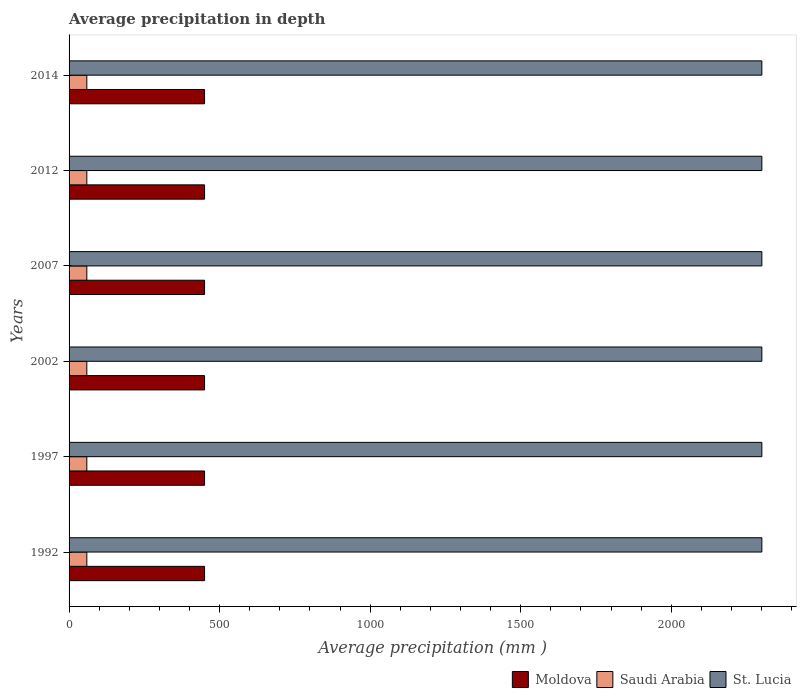Are the number of bars on each tick of the Y-axis equal?
Your response must be concise. Yes. How many bars are there on the 2nd tick from the bottom?
Your response must be concise. 3. In how many cases, is the number of bars for a given year not equal to the number of legend labels?
Your answer should be compact. 0. What is the average precipitation in Saudi Arabia in 1997?
Your answer should be compact. 59. Across all years, what is the maximum average precipitation in Moldova?
Provide a succinct answer. 450. Across all years, what is the minimum average precipitation in Saudi Arabia?
Ensure brevity in your answer.  59. What is the total average precipitation in St. Lucia in the graph?
Make the answer very short. 1.38e+04. What is the difference between the average precipitation in Moldova in 2014 and the average precipitation in Saudi Arabia in 2012?
Provide a short and direct response. 391. What is the average average precipitation in St. Lucia per year?
Your answer should be very brief. 2301. In the year 1997, what is the difference between the average precipitation in Saudi Arabia and average precipitation in Moldova?
Offer a terse response. -391. What is the ratio of the average precipitation in Moldova in 2002 to that in 2012?
Offer a very short reply. 1. Is the difference between the average precipitation in Saudi Arabia in 2007 and 2014 greater than the difference between the average precipitation in Moldova in 2007 and 2014?
Provide a succinct answer. No. What is the difference between the highest and the second highest average precipitation in Saudi Arabia?
Ensure brevity in your answer.  0. What is the difference between the highest and the lowest average precipitation in Saudi Arabia?
Offer a terse response. 0. In how many years, is the average precipitation in Moldova greater than the average average precipitation in Moldova taken over all years?
Provide a succinct answer. 0. What does the 1st bar from the top in 2014 represents?
Provide a succinct answer. St. Lucia. What does the 2nd bar from the bottom in 1997 represents?
Give a very brief answer. Saudi Arabia. Is it the case that in every year, the sum of the average precipitation in St. Lucia and average precipitation in Moldova is greater than the average precipitation in Saudi Arabia?
Your response must be concise. Yes. How many bars are there?
Your response must be concise. 18. How many years are there in the graph?
Provide a short and direct response. 6. What is the difference between two consecutive major ticks on the X-axis?
Ensure brevity in your answer.  500. Are the values on the major ticks of X-axis written in scientific E-notation?
Provide a short and direct response. No. Does the graph contain grids?
Keep it short and to the point. No. Where does the legend appear in the graph?
Your answer should be very brief. Bottom right. How many legend labels are there?
Give a very brief answer. 3. What is the title of the graph?
Ensure brevity in your answer.  Average precipitation in depth. What is the label or title of the X-axis?
Keep it short and to the point. Average precipitation (mm ). What is the label or title of the Y-axis?
Make the answer very short. Years. What is the Average precipitation (mm ) of Moldova in 1992?
Provide a short and direct response. 450. What is the Average precipitation (mm ) in St. Lucia in 1992?
Your answer should be very brief. 2301. What is the Average precipitation (mm ) of Moldova in 1997?
Offer a very short reply. 450. What is the Average precipitation (mm ) of Saudi Arabia in 1997?
Offer a very short reply. 59. What is the Average precipitation (mm ) in St. Lucia in 1997?
Make the answer very short. 2301. What is the Average precipitation (mm ) in Moldova in 2002?
Give a very brief answer. 450. What is the Average precipitation (mm ) of Saudi Arabia in 2002?
Provide a short and direct response. 59. What is the Average precipitation (mm ) in St. Lucia in 2002?
Give a very brief answer. 2301. What is the Average precipitation (mm ) in Moldova in 2007?
Provide a succinct answer. 450. What is the Average precipitation (mm ) of St. Lucia in 2007?
Your answer should be very brief. 2301. What is the Average precipitation (mm ) of Moldova in 2012?
Keep it short and to the point. 450. What is the Average precipitation (mm ) of St. Lucia in 2012?
Your answer should be very brief. 2301. What is the Average precipitation (mm ) in Moldova in 2014?
Give a very brief answer. 450. What is the Average precipitation (mm ) of Saudi Arabia in 2014?
Your answer should be compact. 59. What is the Average precipitation (mm ) of St. Lucia in 2014?
Provide a short and direct response. 2301. Across all years, what is the maximum Average precipitation (mm ) in Moldova?
Your response must be concise. 450. Across all years, what is the maximum Average precipitation (mm ) of St. Lucia?
Your response must be concise. 2301. Across all years, what is the minimum Average precipitation (mm ) in Moldova?
Ensure brevity in your answer.  450. Across all years, what is the minimum Average precipitation (mm ) in Saudi Arabia?
Offer a very short reply. 59. Across all years, what is the minimum Average precipitation (mm ) of St. Lucia?
Give a very brief answer. 2301. What is the total Average precipitation (mm ) of Moldova in the graph?
Your answer should be very brief. 2700. What is the total Average precipitation (mm ) of Saudi Arabia in the graph?
Provide a short and direct response. 354. What is the total Average precipitation (mm ) of St. Lucia in the graph?
Your answer should be very brief. 1.38e+04. What is the difference between the Average precipitation (mm ) in St. Lucia in 1992 and that in 1997?
Your response must be concise. 0. What is the difference between the Average precipitation (mm ) in Moldova in 1992 and that in 2002?
Offer a very short reply. 0. What is the difference between the Average precipitation (mm ) of Saudi Arabia in 1992 and that in 2002?
Offer a terse response. 0. What is the difference between the Average precipitation (mm ) in Moldova in 1992 and that in 2012?
Provide a succinct answer. 0. What is the difference between the Average precipitation (mm ) in Moldova in 1992 and that in 2014?
Give a very brief answer. 0. What is the difference between the Average precipitation (mm ) of Saudi Arabia in 1992 and that in 2014?
Make the answer very short. 0. What is the difference between the Average precipitation (mm ) of Saudi Arabia in 1997 and that in 2002?
Give a very brief answer. 0. What is the difference between the Average precipitation (mm ) of St. Lucia in 1997 and that in 2002?
Keep it short and to the point. 0. What is the difference between the Average precipitation (mm ) in Moldova in 1997 and that in 2007?
Offer a terse response. 0. What is the difference between the Average precipitation (mm ) in Moldova in 1997 and that in 2014?
Your answer should be very brief. 0. What is the difference between the Average precipitation (mm ) in St. Lucia in 1997 and that in 2014?
Keep it short and to the point. 0. What is the difference between the Average precipitation (mm ) in St. Lucia in 2002 and that in 2007?
Your response must be concise. 0. What is the difference between the Average precipitation (mm ) in Saudi Arabia in 2002 and that in 2012?
Keep it short and to the point. 0. What is the difference between the Average precipitation (mm ) of St. Lucia in 2002 and that in 2012?
Keep it short and to the point. 0. What is the difference between the Average precipitation (mm ) of Saudi Arabia in 2002 and that in 2014?
Offer a very short reply. 0. What is the difference between the Average precipitation (mm ) of Saudi Arabia in 2007 and that in 2012?
Your response must be concise. 0. What is the difference between the Average precipitation (mm ) of Moldova in 2007 and that in 2014?
Make the answer very short. 0. What is the difference between the Average precipitation (mm ) in Saudi Arabia in 2007 and that in 2014?
Make the answer very short. 0. What is the difference between the Average precipitation (mm ) in St. Lucia in 2007 and that in 2014?
Your response must be concise. 0. What is the difference between the Average precipitation (mm ) of Saudi Arabia in 2012 and that in 2014?
Your response must be concise. 0. What is the difference between the Average precipitation (mm ) in Moldova in 1992 and the Average precipitation (mm ) in Saudi Arabia in 1997?
Provide a short and direct response. 391. What is the difference between the Average precipitation (mm ) in Moldova in 1992 and the Average precipitation (mm ) in St. Lucia in 1997?
Give a very brief answer. -1851. What is the difference between the Average precipitation (mm ) in Saudi Arabia in 1992 and the Average precipitation (mm ) in St. Lucia in 1997?
Provide a succinct answer. -2242. What is the difference between the Average precipitation (mm ) in Moldova in 1992 and the Average precipitation (mm ) in Saudi Arabia in 2002?
Keep it short and to the point. 391. What is the difference between the Average precipitation (mm ) in Moldova in 1992 and the Average precipitation (mm ) in St. Lucia in 2002?
Make the answer very short. -1851. What is the difference between the Average precipitation (mm ) in Saudi Arabia in 1992 and the Average precipitation (mm ) in St. Lucia in 2002?
Offer a very short reply. -2242. What is the difference between the Average precipitation (mm ) of Moldova in 1992 and the Average precipitation (mm ) of Saudi Arabia in 2007?
Your answer should be very brief. 391. What is the difference between the Average precipitation (mm ) in Moldova in 1992 and the Average precipitation (mm ) in St. Lucia in 2007?
Offer a very short reply. -1851. What is the difference between the Average precipitation (mm ) of Saudi Arabia in 1992 and the Average precipitation (mm ) of St. Lucia in 2007?
Give a very brief answer. -2242. What is the difference between the Average precipitation (mm ) of Moldova in 1992 and the Average precipitation (mm ) of Saudi Arabia in 2012?
Keep it short and to the point. 391. What is the difference between the Average precipitation (mm ) in Moldova in 1992 and the Average precipitation (mm ) in St. Lucia in 2012?
Make the answer very short. -1851. What is the difference between the Average precipitation (mm ) in Saudi Arabia in 1992 and the Average precipitation (mm ) in St. Lucia in 2012?
Give a very brief answer. -2242. What is the difference between the Average precipitation (mm ) in Moldova in 1992 and the Average precipitation (mm ) in Saudi Arabia in 2014?
Offer a very short reply. 391. What is the difference between the Average precipitation (mm ) of Moldova in 1992 and the Average precipitation (mm ) of St. Lucia in 2014?
Provide a short and direct response. -1851. What is the difference between the Average precipitation (mm ) of Saudi Arabia in 1992 and the Average precipitation (mm ) of St. Lucia in 2014?
Your answer should be compact. -2242. What is the difference between the Average precipitation (mm ) of Moldova in 1997 and the Average precipitation (mm ) of Saudi Arabia in 2002?
Your answer should be compact. 391. What is the difference between the Average precipitation (mm ) of Moldova in 1997 and the Average precipitation (mm ) of St. Lucia in 2002?
Provide a short and direct response. -1851. What is the difference between the Average precipitation (mm ) of Saudi Arabia in 1997 and the Average precipitation (mm ) of St. Lucia in 2002?
Keep it short and to the point. -2242. What is the difference between the Average precipitation (mm ) in Moldova in 1997 and the Average precipitation (mm ) in Saudi Arabia in 2007?
Provide a short and direct response. 391. What is the difference between the Average precipitation (mm ) of Moldova in 1997 and the Average precipitation (mm ) of St. Lucia in 2007?
Your answer should be very brief. -1851. What is the difference between the Average precipitation (mm ) in Saudi Arabia in 1997 and the Average precipitation (mm ) in St. Lucia in 2007?
Your answer should be compact. -2242. What is the difference between the Average precipitation (mm ) of Moldova in 1997 and the Average precipitation (mm ) of Saudi Arabia in 2012?
Give a very brief answer. 391. What is the difference between the Average precipitation (mm ) of Moldova in 1997 and the Average precipitation (mm ) of St. Lucia in 2012?
Offer a very short reply. -1851. What is the difference between the Average precipitation (mm ) of Saudi Arabia in 1997 and the Average precipitation (mm ) of St. Lucia in 2012?
Your answer should be very brief. -2242. What is the difference between the Average precipitation (mm ) of Moldova in 1997 and the Average precipitation (mm ) of Saudi Arabia in 2014?
Give a very brief answer. 391. What is the difference between the Average precipitation (mm ) of Moldova in 1997 and the Average precipitation (mm ) of St. Lucia in 2014?
Your answer should be compact. -1851. What is the difference between the Average precipitation (mm ) of Saudi Arabia in 1997 and the Average precipitation (mm ) of St. Lucia in 2014?
Provide a short and direct response. -2242. What is the difference between the Average precipitation (mm ) of Moldova in 2002 and the Average precipitation (mm ) of Saudi Arabia in 2007?
Provide a succinct answer. 391. What is the difference between the Average precipitation (mm ) in Moldova in 2002 and the Average precipitation (mm ) in St. Lucia in 2007?
Provide a succinct answer. -1851. What is the difference between the Average precipitation (mm ) of Saudi Arabia in 2002 and the Average precipitation (mm ) of St. Lucia in 2007?
Provide a short and direct response. -2242. What is the difference between the Average precipitation (mm ) in Moldova in 2002 and the Average precipitation (mm ) in Saudi Arabia in 2012?
Provide a succinct answer. 391. What is the difference between the Average precipitation (mm ) in Moldova in 2002 and the Average precipitation (mm ) in St. Lucia in 2012?
Keep it short and to the point. -1851. What is the difference between the Average precipitation (mm ) of Saudi Arabia in 2002 and the Average precipitation (mm ) of St. Lucia in 2012?
Your response must be concise. -2242. What is the difference between the Average precipitation (mm ) in Moldova in 2002 and the Average precipitation (mm ) in Saudi Arabia in 2014?
Offer a terse response. 391. What is the difference between the Average precipitation (mm ) of Moldova in 2002 and the Average precipitation (mm ) of St. Lucia in 2014?
Your answer should be compact. -1851. What is the difference between the Average precipitation (mm ) of Saudi Arabia in 2002 and the Average precipitation (mm ) of St. Lucia in 2014?
Offer a very short reply. -2242. What is the difference between the Average precipitation (mm ) in Moldova in 2007 and the Average precipitation (mm ) in Saudi Arabia in 2012?
Ensure brevity in your answer.  391. What is the difference between the Average precipitation (mm ) in Moldova in 2007 and the Average precipitation (mm ) in St. Lucia in 2012?
Offer a very short reply. -1851. What is the difference between the Average precipitation (mm ) in Saudi Arabia in 2007 and the Average precipitation (mm ) in St. Lucia in 2012?
Your answer should be compact. -2242. What is the difference between the Average precipitation (mm ) of Moldova in 2007 and the Average precipitation (mm ) of Saudi Arabia in 2014?
Ensure brevity in your answer.  391. What is the difference between the Average precipitation (mm ) of Moldova in 2007 and the Average precipitation (mm ) of St. Lucia in 2014?
Offer a terse response. -1851. What is the difference between the Average precipitation (mm ) of Saudi Arabia in 2007 and the Average precipitation (mm ) of St. Lucia in 2014?
Offer a very short reply. -2242. What is the difference between the Average precipitation (mm ) in Moldova in 2012 and the Average precipitation (mm ) in Saudi Arabia in 2014?
Your answer should be compact. 391. What is the difference between the Average precipitation (mm ) of Moldova in 2012 and the Average precipitation (mm ) of St. Lucia in 2014?
Your answer should be very brief. -1851. What is the difference between the Average precipitation (mm ) of Saudi Arabia in 2012 and the Average precipitation (mm ) of St. Lucia in 2014?
Give a very brief answer. -2242. What is the average Average precipitation (mm ) of Moldova per year?
Ensure brevity in your answer.  450. What is the average Average precipitation (mm ) of Saudi Arabia per year?
Make the answer very short. 59. What is the average Average precipitation (mm ) in St. Lucia per year?
Offer a terse response. 2301. In the year 1992, what is the difference between the Average precipitation (mm ) of Moldova and Average precipitation (mm ) of Saudi Arabia?
Give a very brief answer. 391. In the year 1992, what is the difference between the Average precipitation (mm ) of Moldova and Average precipitation (mm ) of St. Lucia?
Offer a very short reply. -1851. In the year 1992, what is the difference between the Average precipitation (mm ) in Saudi Arabia and Average precipitation (mm ) in St. Lucia?
Keep it short and to the point. -2242. In the year 1997, what is the difference between the Average precipitation (mm ) in Moldova and Average precipitation (mm ) in Saudi Arabia?
Your answer should be very brief. 391. In the year 1997, what is the difference between the Average precipitation (mm ) of Moldova and Average precipitation (mm ) of St. Lucia?
Provide a succinct answer. -1851. In the year 1997, what is the difference between the Average precipitation (mm ) of Saudi Arabia and Average precipitation (mm ) of St. Lucia?
Ensure brevity in your answer.  -2242. In the year 2002, what is the difference between the Average precipitation (mm ) in Moldova and Average precipitation (mm ) in Saudi Arabia?
Offer a very short reply. 391. In the year 2002, what is the difference between the Average precipitation (mm ) in Moldova and Average precipitation (mm ) in St. Lucia?
Offer a very short reply. -1851. In the year 2002, what is the difference between the Average precipitation (mm ) in Saudi Arabia and Average precipitation (mm ) in St. Lucia?
Give a very brief answer. -2242. In the year 2007, what is the difference between the Average precipitation (mm ) in Moldova and Average precipitation (mm ) in Saudi Arabia?
Ensure brevity in your answer.  391. In the year 2007, what is the difference between the Average precipitation (mm ) in Moldova and Average precipitation (mm ) in St. Lucia?
Your response must be concise. -1851. In the year 2007, what is the difference between the Average precipitation (mm ) of Saudi Arabia and Average precipitation (mm ) of St. Lucia?
Provide a succinct answer. -2242. In the year 2012, what is the difference between the Average precipitation (mm ) of Moldova and Average precipitation (mm ) of Saudi Arabia?
Keep it short and to the point. 391. In the year 2012, what is the difference between the Average precipitation (mm ) in Moldova and Average precipitation (mm ) in St. Lucia?
Your response must be concise. -1851. In the year 2012, what is the difference between the Average precipitation (mm ) in Saudi Arabia and Average precipitation (mm ) in St. Lucia?
Keep it short and to the point. -2242. In the year 2014, what is the difference between the Average precipitation (mm ) of Moldova and Average precipitation (mm ) of Saudi Arabia?
Provide a succinct answer. 391. In the year 2014, what is the difference between the Average precipitation (mm ) in Moldova and Average precipitation (mm ) in St. Lucia?
Keep it short and to the point. -1851. In the year 2014, what is the difference between the Average precipitation (mm ) in Saudi Arabia and Average precipitation (mm ) in St. Lucia?
Your answer should be compact. -2242. What is the ratio of the Average precipitation (mm ) in Moldova in 1992 to that in 2002?
Your answer should be compact. 1. What is the ratio of the Average precipitation (mm ) of Saudi Arabia in 1992 to that in 2002?
Provide a short and direct response. 1. What is the ratio of the Average precipitation (mm ) in Moldova in 1992 to that in 2007?
Offer a terse response. 1. What is the ratio of the Average precipitation (mm ) of Saudi Arabia in 1992 to that in 2007?
Ensure brevity in your answer.  1. What is the ratio of the Average precipitation (mm ) of Saudi Arabia in 1992 to that in 2012?
Give a very brief answer. 1. What is the ratio of the Average precipitation (mm ) in St. Lucia in 1992 to that in 2012?
Ensure brevity in your answer.  1. What is the ratio of the Average precipitation (mm ) in Moldova in 1997 to that in 2002?
Your answer should be compact. 1. What is the ratio of the Average precipitation (mm ) of Saudi Arabia in 1997 to that in 2002?
Your response must be concise. 1. What is the ratio of the Average precipitation (mm ) in St. Lucia in 1997 to that in 2002?
Your response must be concise. 1. What is the ratio of the Average precipitation (mm ) of Saudi Arabia in 1997 to that in 2007?
Provide a short and direct response. 1. What is the ratio of the Average precipitation (mm ) of Moldova in 1997 to that in 2012?
Provide a short and direct response. 1. What is the ratio of the Average precipitation (mm ) in Saudi Arabia in 1997 to that in 2012?
Your answer should be very brief. 1. What is the ratio of the Average precipitation (mm ) in St. Lucia in 1997 to that in 2012?
Ensure brevity in your answer.  1. What is the ratio of the Average precipitation (mm ) in Moldova in 2002 to that in 2007?
Offer a very short reply. 1. What is the ratio of the Average precipitation (mm ) in Saudi Arabia in 2002 to that in 2012?
Your answer should be compact. 1. What is the ratio of the Average precipitation (mm ) in St. Lucia in 2002 to that in 2012?
Give a very brief answer. 1. What is the ratio of the Average precipitation (mm ) in Moldova in 2002 to that in 2014?
Provide a short and direct response. 1. What is the ratio of the Average precipitation (mm ) of Saudi Arabia in 2002 to that in 2014?
Give a very brief answer. 1. What is the ratio of the Average precipitation (mm ) of St. Lucia in 2002 to that in 2014?
Make the answer very short. 1. What is the ratio of the Average precipitation (mm ) in Moldova in 2007 to that in 2014?
Give a very brief answer. 1. What is the ratio of the Average precipitation (mm ) of Moldova in 2012 to that in 2014?
Make the answer very short. 1. What is the ratio of the Average precipitation (mm ) in St. Lucia in 2012 to that in 2014?
Offer a very short reply. 1. What is the difference between the highest and the second highest Average precipitation (mm ) of St. Lucia?
Offer a very short reply. 0. What is the difference between the highest and the lowest Average precipitation (mm ) in St. Lucia?
Give a very brief answer. 0. 